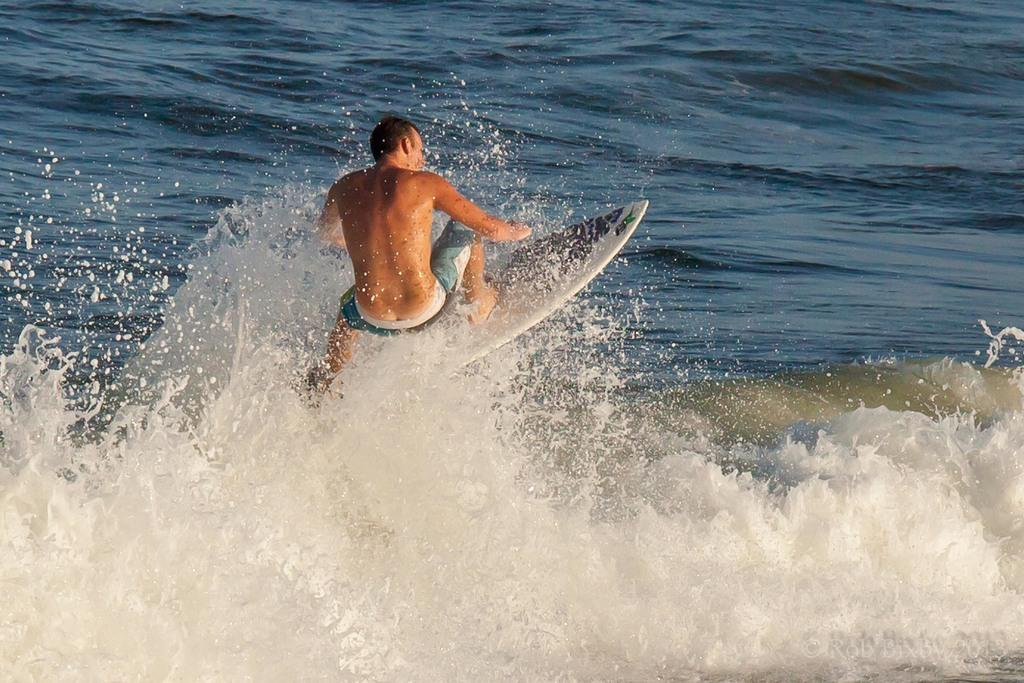What activity is the person in the image engaged in? The person is skiing in the image. Where is the person skiing? The person is skiing in the ocean. At what time of day was the image taken? The image was taken during the day. What type of street can be seen in the background of the image? There is no street visible in the image; the person is skiing in the ocean. 